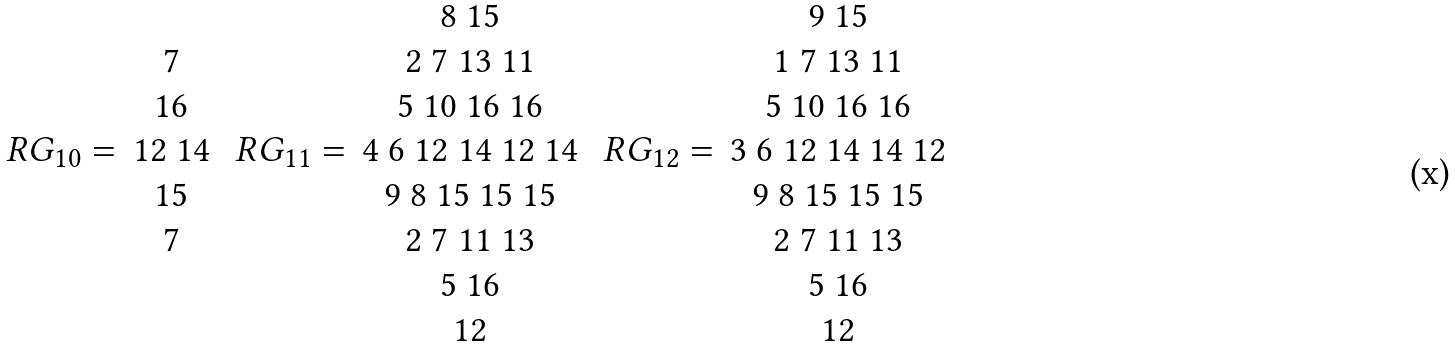<formula> <loc_0><loc_0><loc_500><loc_500>\begin{array} { c c } & \\ & 7 \\ & 1 6 \\ R G _ { 1 0 } = & 1 2 \ 1 4 \\ & 1 5 \\ & 7 \\ & \\ & \\ \end{array} \ \begin{array} { c c } & 8 \ 1 5 \\ & 2 \ 7 \ 1 3 \ 1 1 \\ & 5 \ 1 0 \ 1 6 \ 1 6 \\ R G _ { 1 1 } = & 4 \ 6 \ 1 2 \ 1 4 \ 1 2 \ 1 4 \\ & 9 \ 8 \ 1 5 \ 1 5 \ 1 5 \\ & 2 \ 7 \ 1 1 \ 1 3 \\ & 5 \ 1 6 \\ & 1 2 \\ \end{array} \ \begin{array} { c c } & 9 \ 1 5 \\ & 1 \ 7 \ 1 3 \ 1 1 \\ & 5 \ 1 0 \ 1 6 \ 1 6 \\ R G _ { 1 2 } = & 3 \ 6 \ 1 2 \ 1 4 \ 1 4 \ 1 2 \\ & 9 \ 8 \ 1 5 \ 1 5 \ 1 5 \\ & 2 \ 7 \ 1 1 \ 1 3 \\ & 5 \ 1 6 \\ & 1 2 \\ \end{array}</formula> 